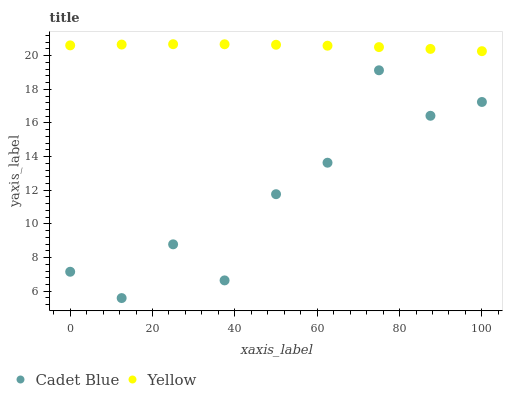Does Cadet Blue have the minimum area under the curve?
Answer yes or no. Yes. Does Yellow have the maximum area under the curve?
Answer yes or no. Yes. Does Yellow have the minimum area under the curve?
Answer yes or no. No. Is Yellow the smoothest?
Answer yes or no. Yes. Is Cadet Blue the roughest?
Answer yes or no. Yes. Is Yellow the roughest?
Answer yes or no. No. Does Cadet Blue have the lowest value?
Answer yes or no. Yes. Does Yellow have the lowest value?
Answer yes or no. No. Does Yellow have the highest value?
Answer yes or no. Yes. Is Cadet Blue less than Yellow?
Answer yes or no. Yes. Is Yellow greater than Cadet Blue?
Answer yes or no. Yes. Does Cadet Blue intersect Yellow?
Answer yes or no. No. 